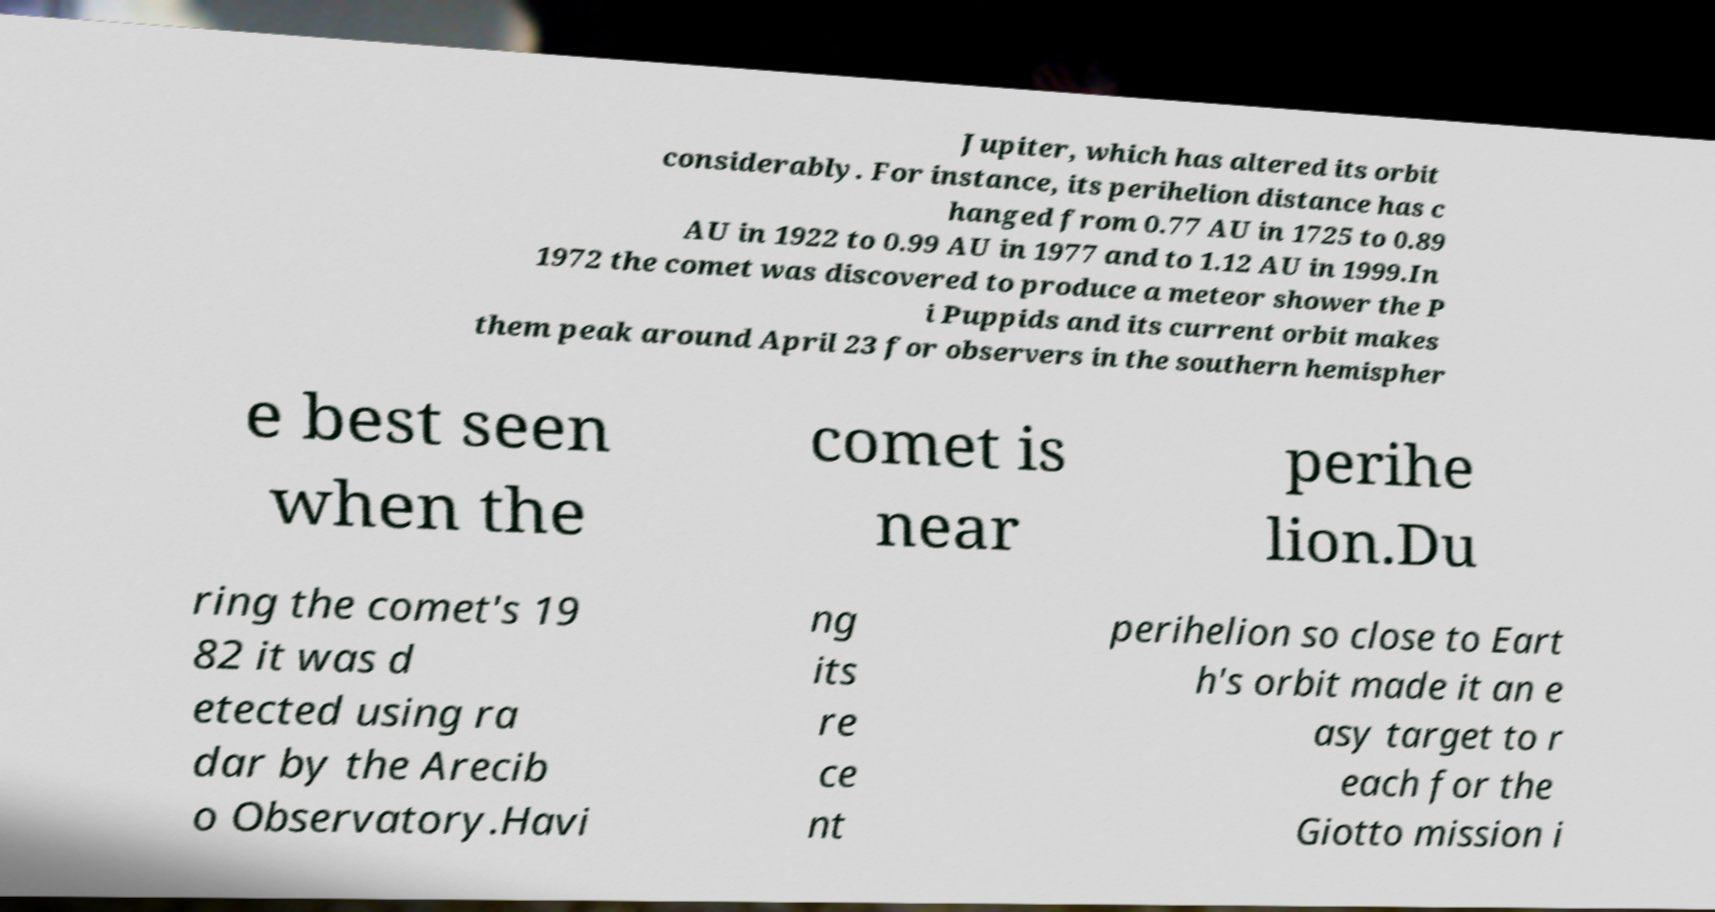Could you assist in decoding the text presented in this image and type it out clearly? Jupiter, which has altered its orbit considerably. For instance, its perihelion distance has c hanged from 0.77 AU in 1725 to 0.89 AU in 1922 to 0.99 AU in 1977 and to 1.12 AU in 1999.In 1972 the comet was discovered to produce a meteor shower the P i Puppids and its current orbit makes them peak around April 23 for observers in the southern hemispher e best seen when the comet is near perihe lion.Du ring the comet's 19 82 it was d etected using ra dar by the Arecib o Observatory.Havi ng its re ce nt perihelion so close to Eart h's orbit made it an e asy target to r each for the Giotto mission i 